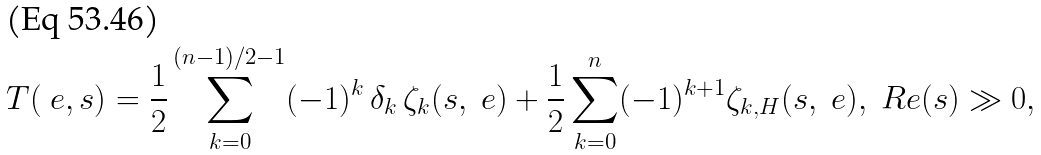Convert formula to latex. <formula><loc_0><loc_0><loc_500><loc_500>T ( \ e , s ) = \frac { 1 } { 2 } \sum _ { k = 0 } ^ { ( n - 1 ) / 2 - 1 } ( - 1 ) ^ { k } \, \delta _ { k } \, \zeta _ { k } ( s , \ e ) + \frac { 1 } { 2 } \sum _ { k = 0 } ^ { n } ( - 1 ) ^ { k + 1 } \zeta _ { k , H } ( s , \ e ) , \ R e ( s ) \gg 0 ,</formula> 